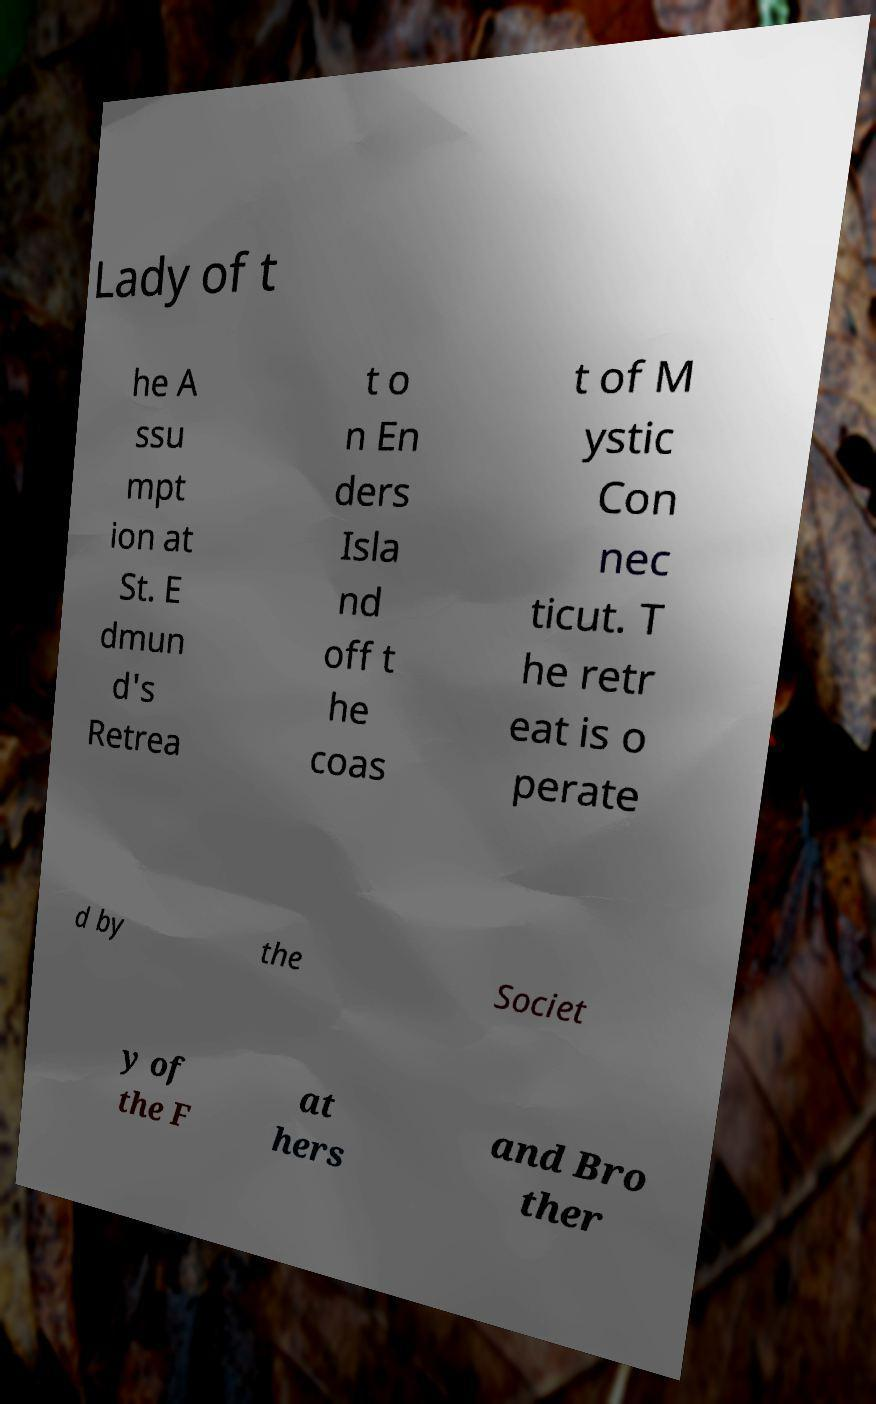Could you extract and type out the text from this image? Lady of t he A ssu mpt ion at St. E dmun d's Retrea t o n En ders Isla nd off t he coas t of M ystic Con nec ticut. T he retr eat is o perate d by the Societ y of the F at hers and Bro ther 